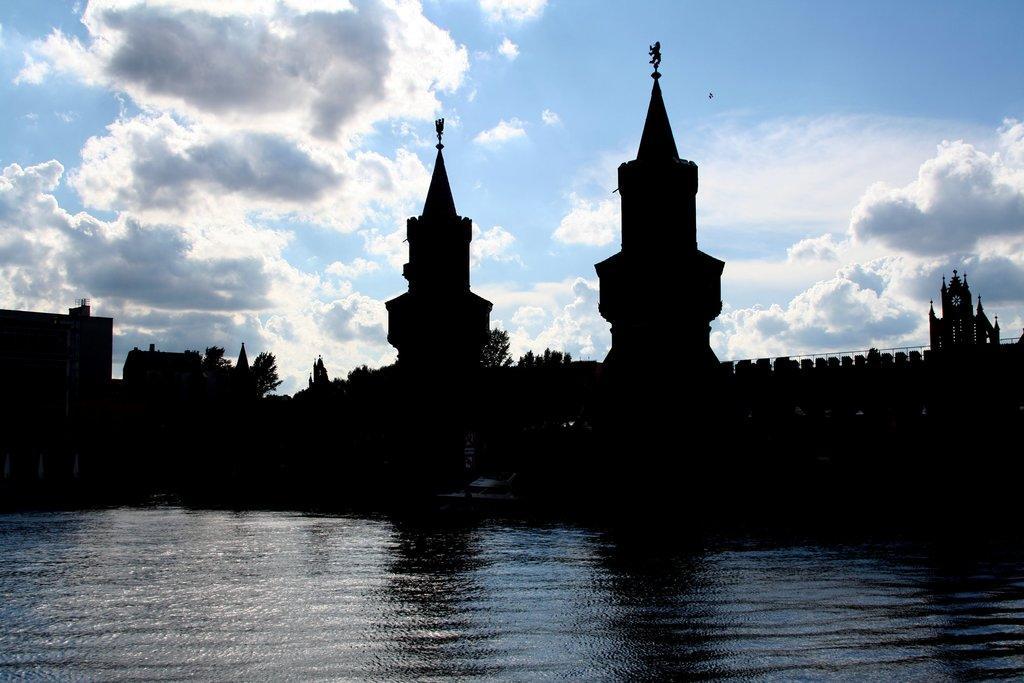How would you summarize this image in a sentence or two? In this image we can see water, boat, towers, trees and sky. Sky is cloudy. 